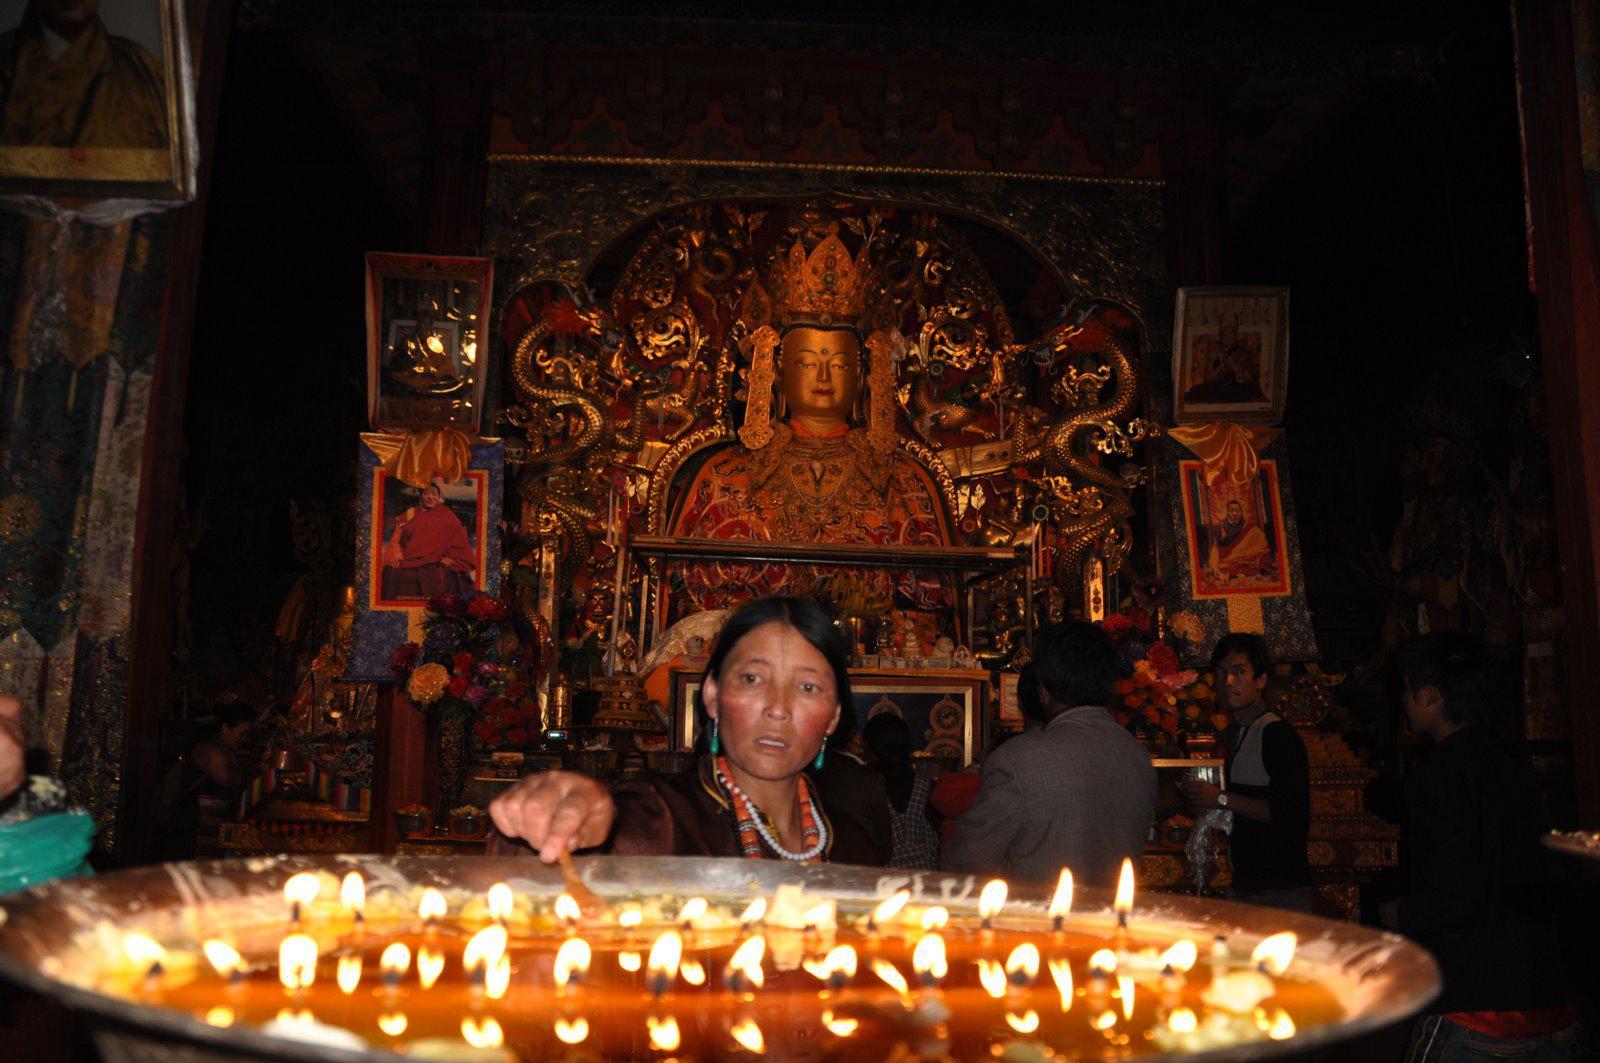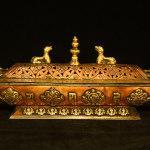The first image is the image on the left, the second image is the image on the right. Given the left and right images, does the statement "There is a conical roof in one of the images." hold true? Answer yes or no. No. The first image is the image on the left, the second image is the image on the right. Given the left and right images, does the statement "At least one image shows a building with a cone-shape atop a cylinder." hold true? Answer yes or no. No. 